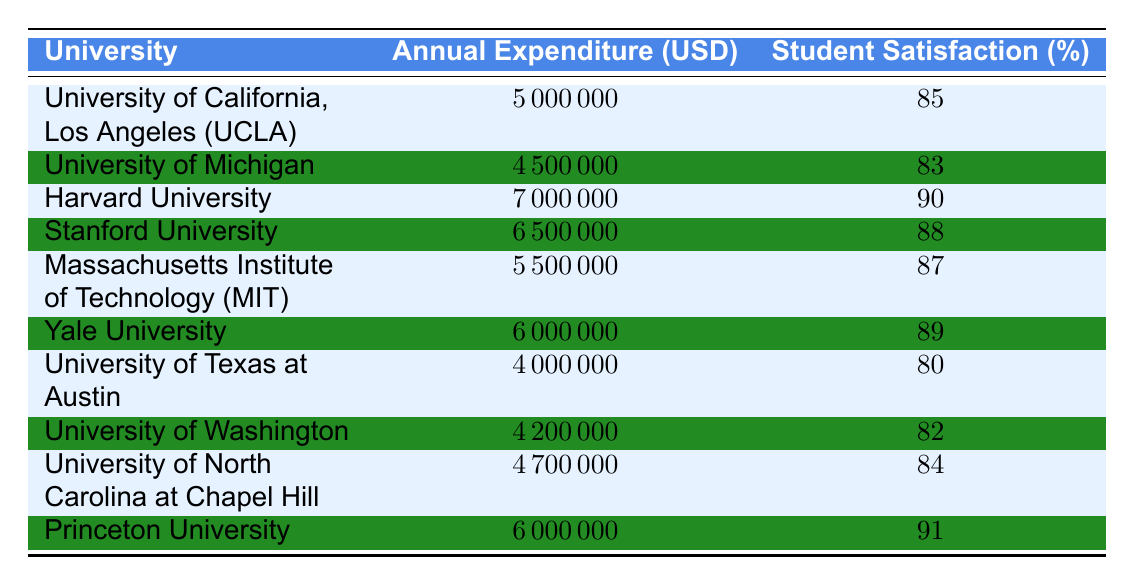What is the annual expenditure for Harvard University? Looking at the table under the "University" column, Harvard University is listed. The corresponding annual expenditure is found in the "Annual Expenditure (USD)" column, which shows 7000000.
Answer: 7000000 Which university has the highest student satisfaction percentage? Scanning the "Student Satisfaction (%)" column, Princeton University has the highest percentage listed at 91.
Answer: 91 What is the average annual expenditure across all universities listed? To find the average, add all annual expenditures: (5000000 + 4500000 + 7000000 + 6500000 + 5500000 + 6000000 + 4000000 + 4200000 + 4700000 + 6000000) = 50000000. Then divide by the number of universities (10): 50000000 / 10 = 5000000.
Answer: 5000000 Is the annual expenditure at the University of California, Los Angeles more than the average annual expenditure? The annual expenditure for UCLA is 5000000, which is equal to the calculated average (5000000). Therefore, UCLA's expenditure is not more than the average.
Answer: No How much more in annual expenditure does Harvard University have compared to the University of Texas at Austin? Harvard's annual expenditure is 7000000 and the University of Texas at Austin's is 4000000. The difference is: 7000000 - 4000000 = 3000000.
Answer: 3000000 What percentage of student satisfaction is associated with the lowest annual expenditure listed? The lowest annual expenditure is 4000000 from the University of Texas at Austin, which corresponds to a student satisfaction percentage of 80.
Answer: 80 Which two universities have a student satisfaction percentage of 85 or higher, and what are their expenditures? Checking the student satisfaction percentages, both UCLA (85) and Yale University (89) are 85 or above. Their expenditures are 5000000 and 6000000, respectively.
Answer: UCLA: 5000000, Yale: 6000000 Is there a university spending more than 6000000 but with student satisfaction below 85? Stanford University spends 6500000 and has a student satisfaction of 88, which is above 85. All universities spending more than 6000000 (Harvard and Yale) have satisfaction percentages above 85 as well.
Answer: No Which university has a student satisfaction percentage that is 5% lower than the highest satisfaction percentage? The highest is 91 from Princeton University. 91 - 5 = 86. MIT has a satisfaction of 87, which is the only university closest to that threshold without going below it.
Answer: MIT 